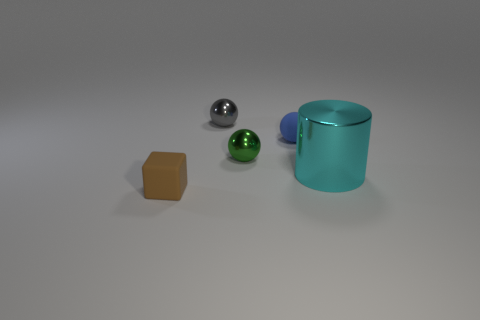Add 4 big rubber spheres. How many objects exist? 9 Subtract all balls. How many objects are left? 2 Add 5 metallic spheres. How many metallic spheres are left? 7 Add 1 tiny purple cylinders. How many tiny purple cylinders exist? 1 Subtract 0 red balls. How many objects are left? 5 Subtract all small cubes. Subtract all green balls. How many objects are left? 3 